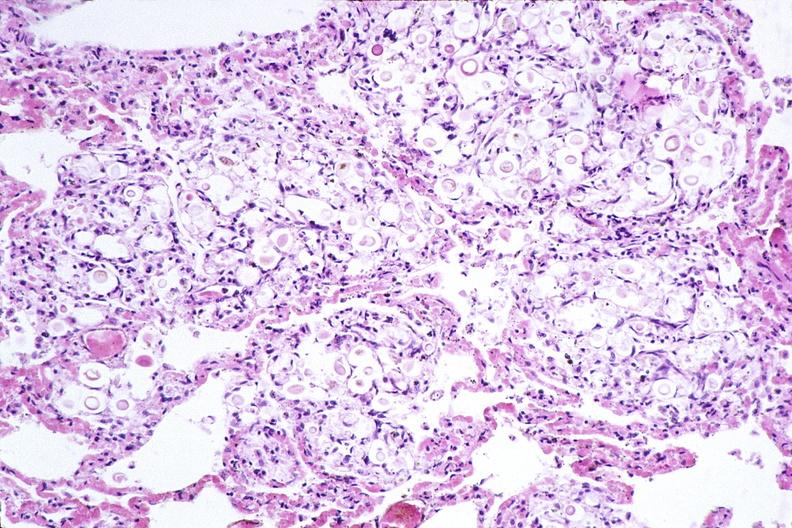does this image show lung, cryptococcal pneumonia?
Answer the question using a single word or phrase. Yes 